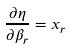Convert formula to latex. <formula><loc_0><loc_0><loc_500><loc_500>\frac { \partial \eta } { \partial \beta _ { r } } = x _ { r }</formula> 